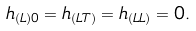<formula> <loc_0><loc_0><loc_500><loc_500>h _ { ( L ) 0 } = h _ { ( L T ) } = h _ { ( L L ) } = 0 .</formula> 